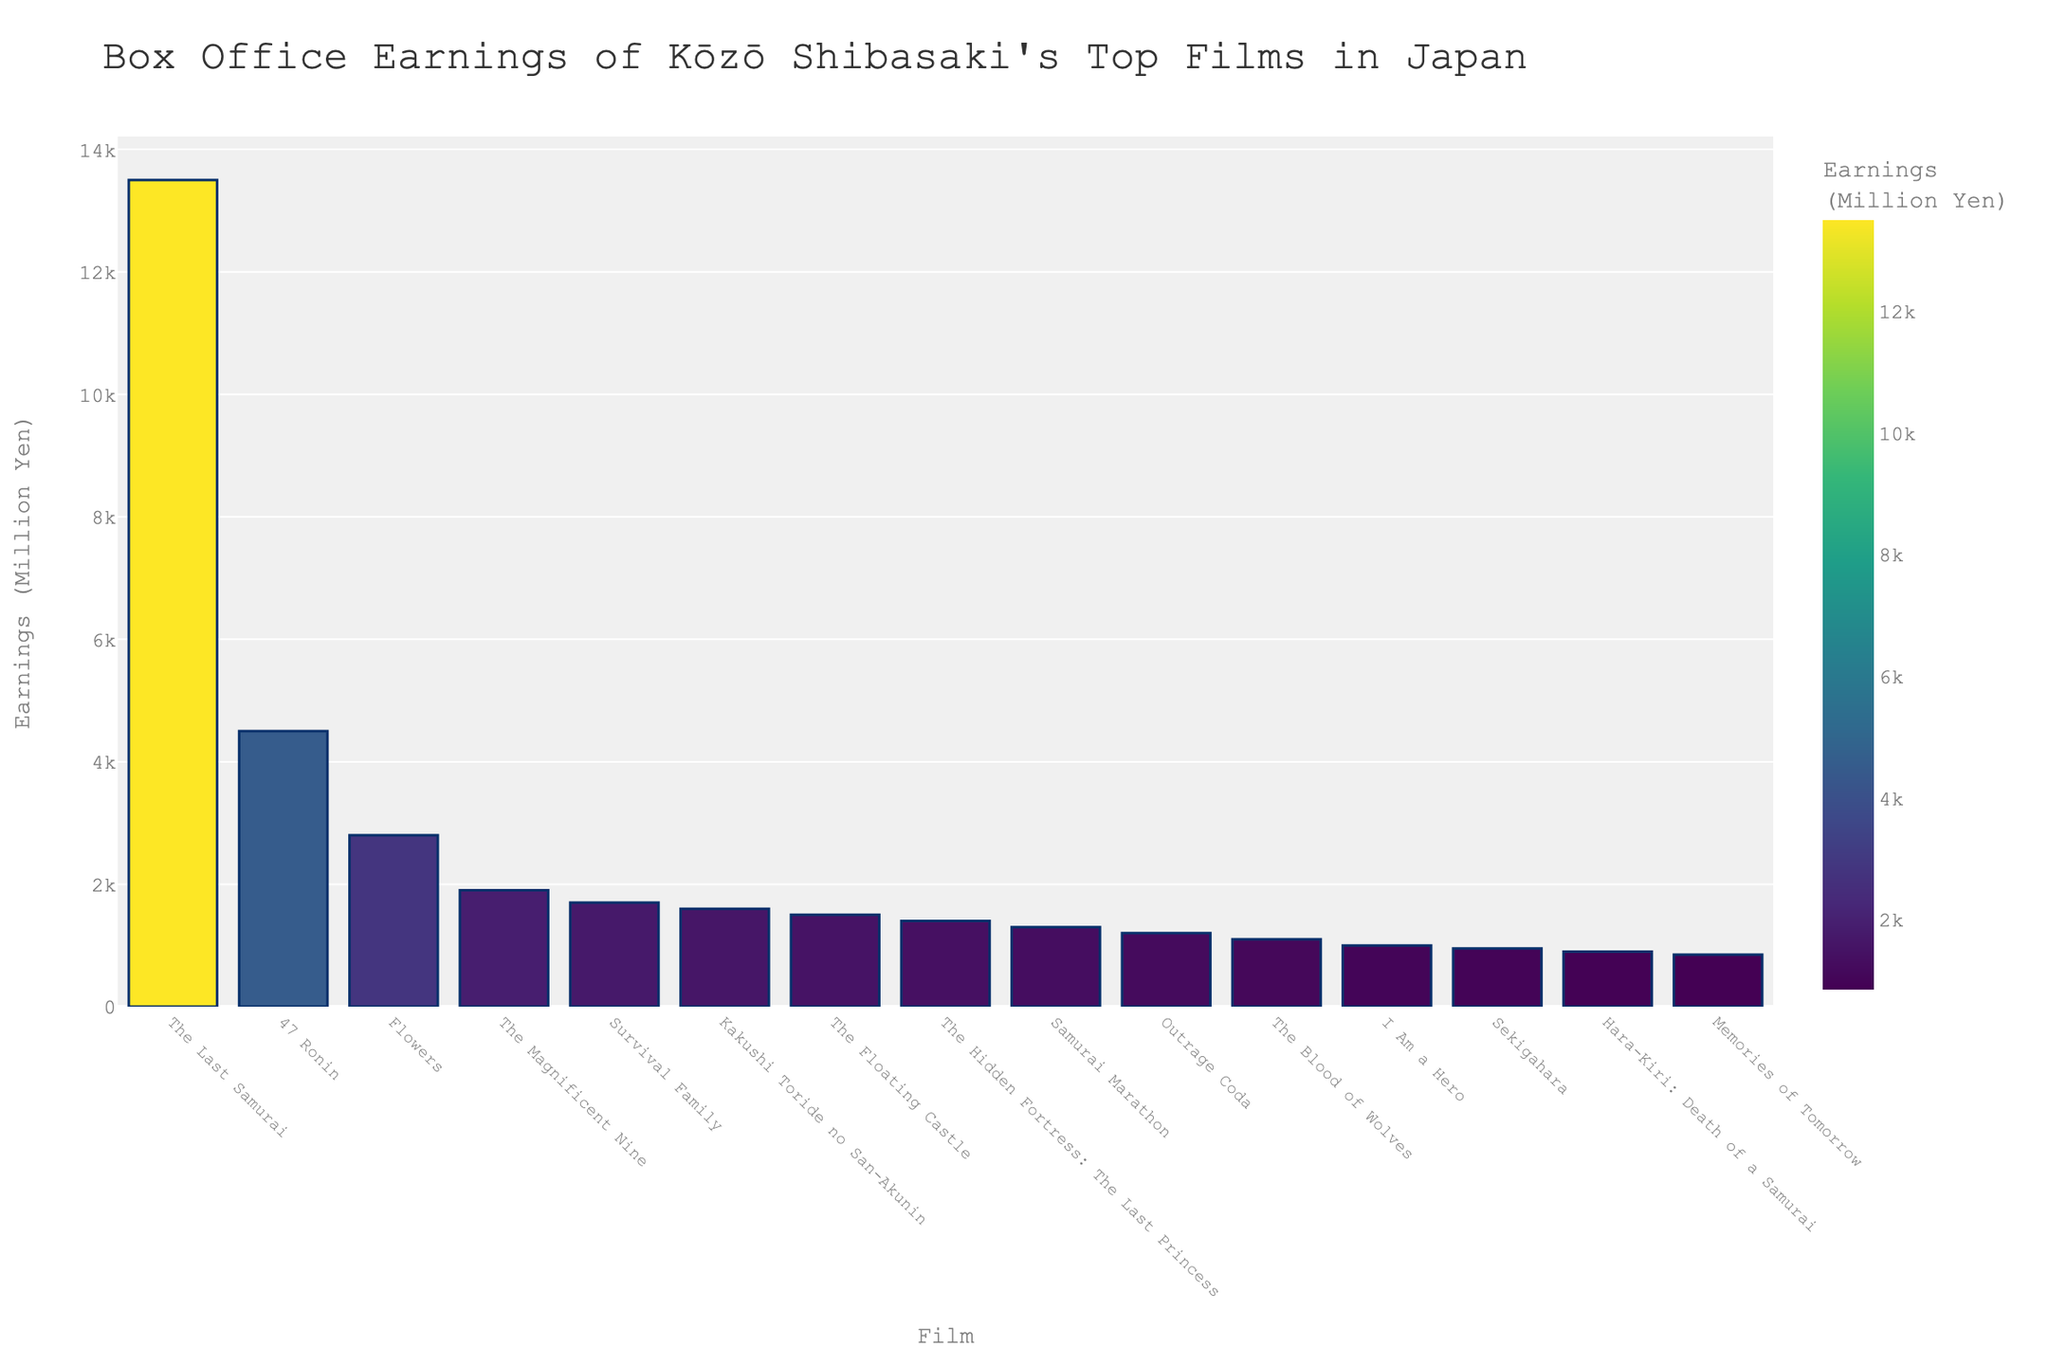what are the top three highest-earning films? Sort the films by their box office earnings and take the top three. The top three highest-earning films are The Last Samurai, 47 Ronin, and Flowers.
Answer: The Last Samurai, 47 Ronin, Flowers what is the total combined box office earnings of the bottom five films? Sum the box office earnings of the five films with the lowest earnings: Memories of Tomorrow (850M Yen), Hara-Kiri: Death of a Samurai (900M Yen), Sekigahara (950M Yen), I Am a Hero (1000M Yen), and The Blood of Wolves (1100M Yen). The total is 850 + 900 + 950 + 1000 + 1100 = 4800
Answer: 4800 which film earned the most at the box office, and how much did it earn? Look for the film with the highest earnings in the chart. The Last Samurai earned the most at the box office with 13500 million yen.
Answer: The Last Samurai, 13500 million yen how much more did The Last Samurai earn compared to 47 Ronin? Subtract the box office earnings of 47 Ronin from The Last Samurai: 13500 - 4500 = 9000
Answer: 9000 which film has a slightly lighter shade of green: The Hidden Fortress: The Last Princess or I Am a Hero? Compare the color intensity representing the earnings. The Hidden Fortress: The Last Princess earned more than I Am a Hero, therefore, it has a lighter shade of green.
Answer: The Hidden Fortress: The Last Princess what is the average box office earnings of the top five films? First, identify the top five films by box office earnings: The Last Samurai, 47 Ronin, Flowers, The Magnificent Nine, and Survival Family. Their earnings are 13500, 4500, 2800, 1900, and 1700 respectively. Calculate the average: (13500 + 4500 + 2800 + 1900 + 1700) / 5 = 4900
Answer: 4900 which film earned the least, and what is its earnings? Look for the film with the lowest earnings. Memories of Tomorrow earned the least with 850 million yen.
Answer: Memories of Tomorrow, 850 million yen what is the difference in box office earnings between The Floating Castle and Samurai Marathon? Subtract the earnings of Samurai Marathon from The Floating Castle: 1500 - 1300 = 200
Answer: 200 what is the median box office earnings of these films? Arrange the earnings in ascending order and find the middle value. The sorted list is 850, 900, 950, 1000, 1100, 1200, 1300, 1400, 1500, 1600, 1700, 1900, 2800, 4500, 13500. The median value is 1300.
Answer: 1300 